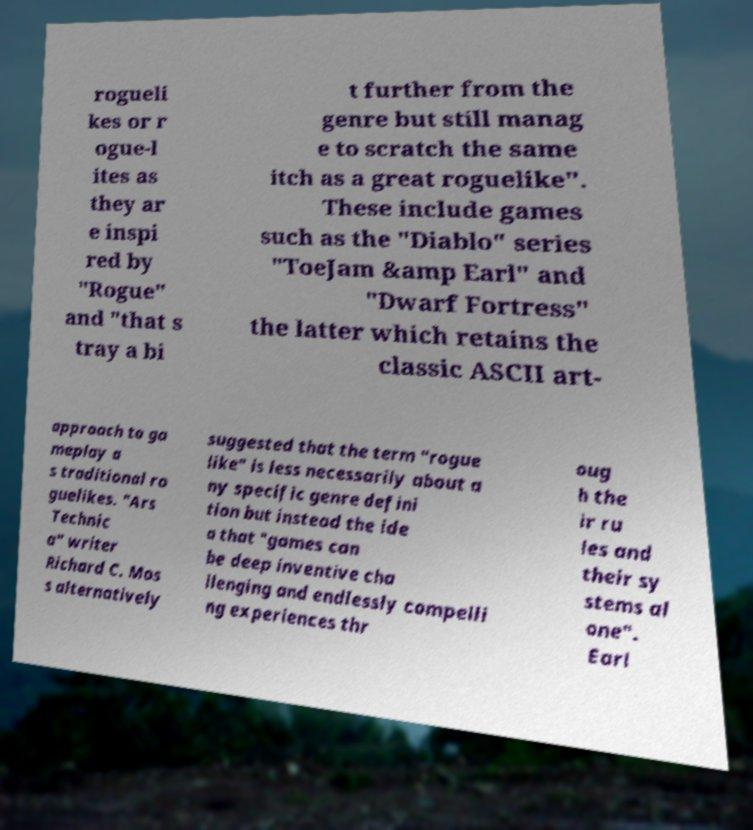I need the written content from this picture converted into text. Can you do that? rogueli kes or r ogue-l ites as they ar e inspi red by "Rogue" and "that s tray a bi t further from the genre but still manag e to scratch the same itch as a great roguelike". These include games such as the "Diablo" series "ToeJam &amp Earl" and "Dwarf Fortress" the latter which retains the classic ASCII art- approach to ga meplay a s traditional ro guelikes. "Ars Technic a" writer Richard C. Mos s alternatively suggested that the term "rogue like" is less necessarily about a ny specific genre defini tion but instead the ide a that "games can be deep inventive cha llenging and endlessly compelli ng experiences thr oug h the ir ru les and their sy stems al one". Earl 